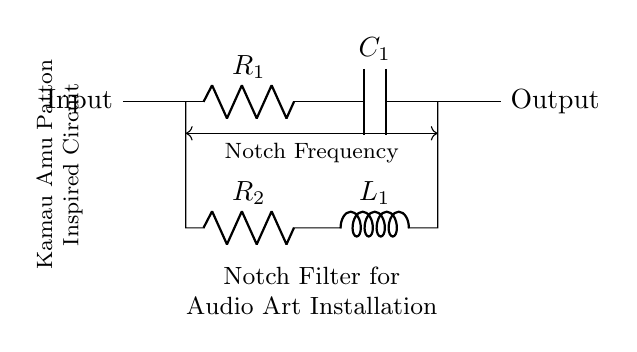What type of filter is represented in this circuit? The circuit diagram depicts a notch filter, which is identifiable by its configuration of resistors, capacitors, and inductors designed to attenuate specific frequencies.
Answer: Notch filter What is the role of the resistor labeled R1? R1 is a series resistor that allows current to flow into the capacitor, affecting the filter's cutoff frequency and overall impedance.
Answer: Series resistor Which component determines the notch frequency in this circuit? The notch frequency is determined primarily by the combination of the resistor R2, inductor L1, and capacitor C1 working together in the circuit's resonant behavior.
Answer: R2, L1, C1 How many components are involved in this notch filter circuit? The filter features four main components: two resistors (R1 and R2), one capacitor (C1), and one inductor (L1).
Answer: Four What is the output in relation to the input in this circuit? The output is derived from the junction after the resistor R2, which is specifically filtered to remove the notch frequency from the input signal.
Answer: Filtered output What is the significance of the labeled notch frequency dimension? The labeled notch frequency dimension indicates the specific frequency at which the filter applies maximum attenuation, crucial for audio applications where particular unwanted frequencies need elimination.
Answer: Maximum attenuation frequency 